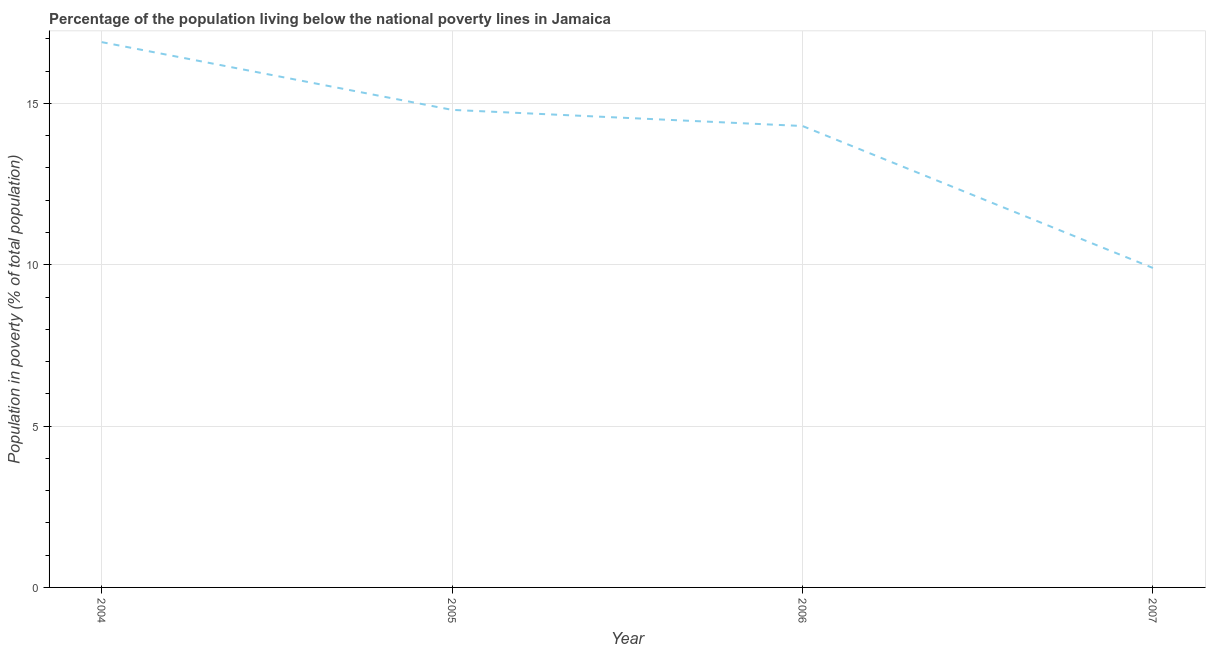In which year was the percentage of population living below poverty line maximum?
Keep it short and to the point. 2004. In which year was the percentage of population living below poverty line minimum?
Provide a short and direct response. 2007. What is the sum of the percentage of population living below poverty line?
Provide a succinct answer. 55.9. What is the difference between the percentage of population living below poverty line in 2005 and 2006?
Provide a short and direct response. 0.5. What is the average percentage of population living below poverty line per year?
Ensure brevity in your answer.  13.97. What is the median percentage of population living below poverty line?
Your response must be concise. 14.55. In how many years, is the percentage of population living below poverty line greater than 14 %?
Give a very brief answer. 3. Do a majority of the years between 2005 and 2007 (inclusive) have percentage of population living below poverty line greater than 7 %?
Make the answer very short. Yes. What is the ratio of the percentage of population living below poverty line in 2004 to that in 2006?
Provide a short and direct response. 1.18. Is the percentage of population living below poverty line in 2004 less than that in 2007?
Offer a very short reply. No. Is the difference between the percentage of population living below poverty line in 2004 and 2007 greater than the difference between any two years?
Offer a very short reply. Yes. What is the difference between the highest and the second highest percentage of population living below poverty line?
Provide a short and direct response. 2.1. What is the difference between the highest and the lowest percentage of population living below poverty line?
Provide a succinct answer. 7. In how many years, is the percentage of population living below poverty line greater than the average percentage of population living below poverty line taken over all years?
Make the answer very short. 3. Does the percentage of population living below poverty line monotonically increase over the years?
Give a very brief answer. No. How many lines are there?
Give a very brief answer. 1. What is the title of the graph?
Ensure brevity in your answer.  Percentage of the population living below the national poverty lines in Jamaica. What is the label or title of the X-axis?
Your response must be concise. Year. What is the label or title of the Y-axis?
Offer a very short reply. Population in poverty (% of total population). What is the Population in poverty (% of total population) of 2004?
Provide a short and direct response. 16.9. What is the Population in poverty (% of total population) of 2006?
Keep it short and to the point. 14.3. What is the difference between the Population in poverty (% of total population) in 2004 and 2005?
Offer a terse response. 2.1. What is the difference between the Population in poverty (% of total population) in 2004 and 2006?
Offer a very short reply. 2.6. What is the difference between the Population in poverty (% of total population) in 2005 and 2006?
Provide a short and direct response. 0.5. What is the difference between the Population in poverty (% of total population) in 2005 and 2007?
Ensure brevity in your answer.  4.9. What is the ratio of the Population in poverty (% of total population) in 2004 to that in 2005?
Provide a short and direct response. 1.14. What is the ratio of the Population in poverty (% of total population) in 2004 to that in 2006?
Provide a short and direct response. 1.18. What is the ratio of the Population in poverty (% of total population) in 2004 to that in 2007?
Offer a terse response. 1.71. What is the ratio of the Population in poverty (% of total population) in 2005 to that in 2006?
Ensure brevity in your answer.  1.03. What is the ratio of the Population in poverty (% of total population) in 2005 to that in 2007?
Your answer should be compact. 1.5. What is the ratio of the Population in poverty (% of total population) in 2006 to that in 2007?
Ensure brevity in your answer.  1.44. 